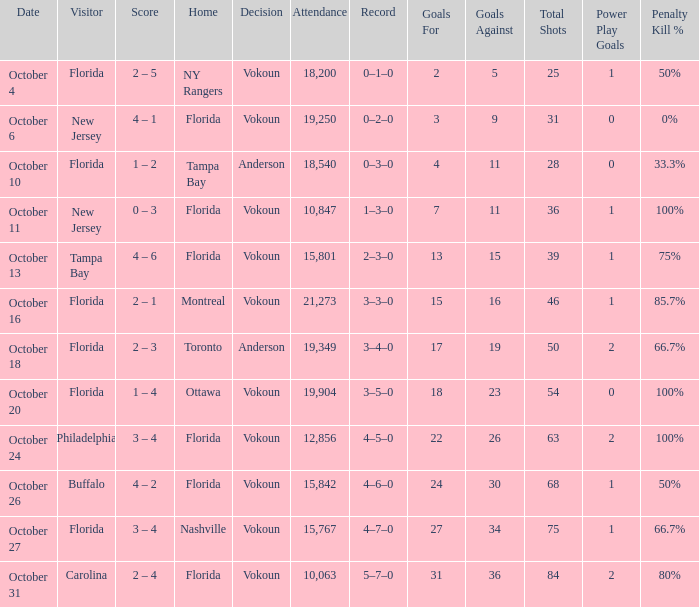What was the score on October 31? 2 – 4. 